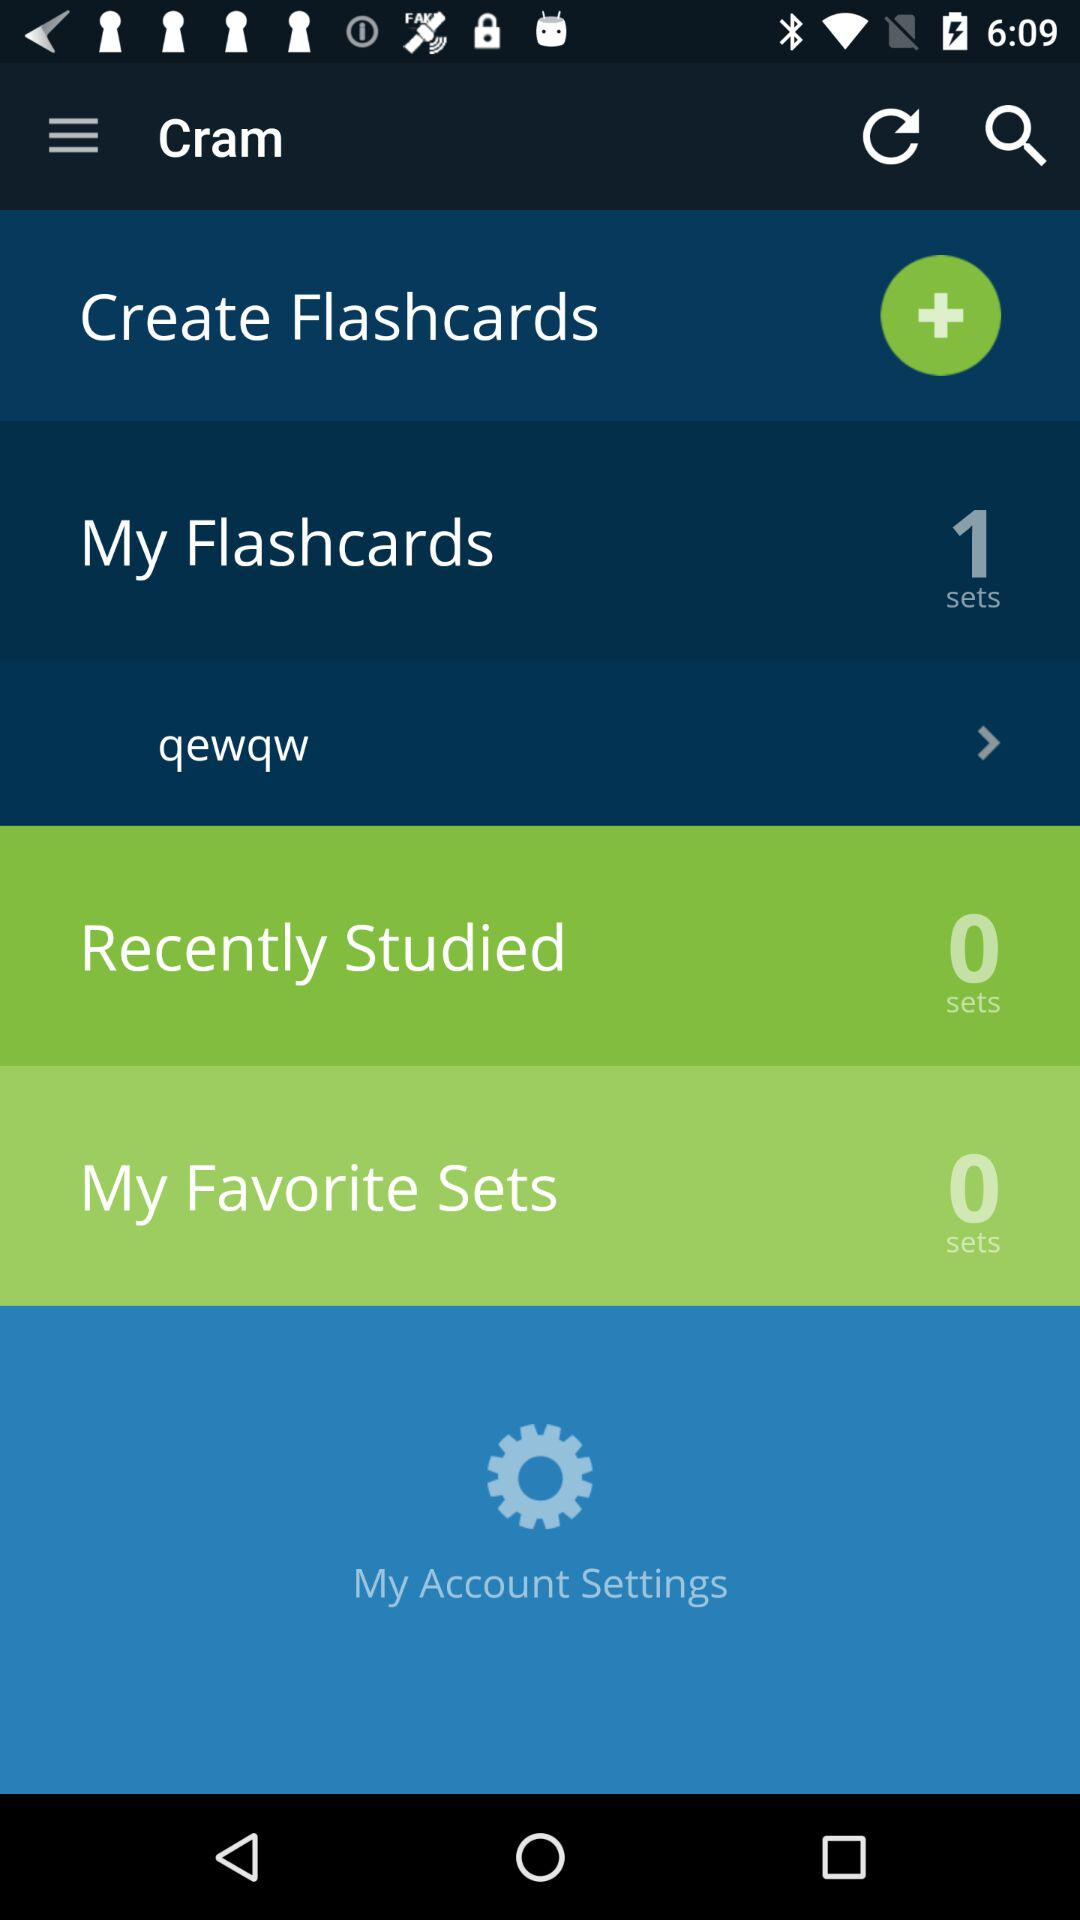How many sets are there in "My Favorite Sets"? There are 0 sets in "My Favorite Sets". 